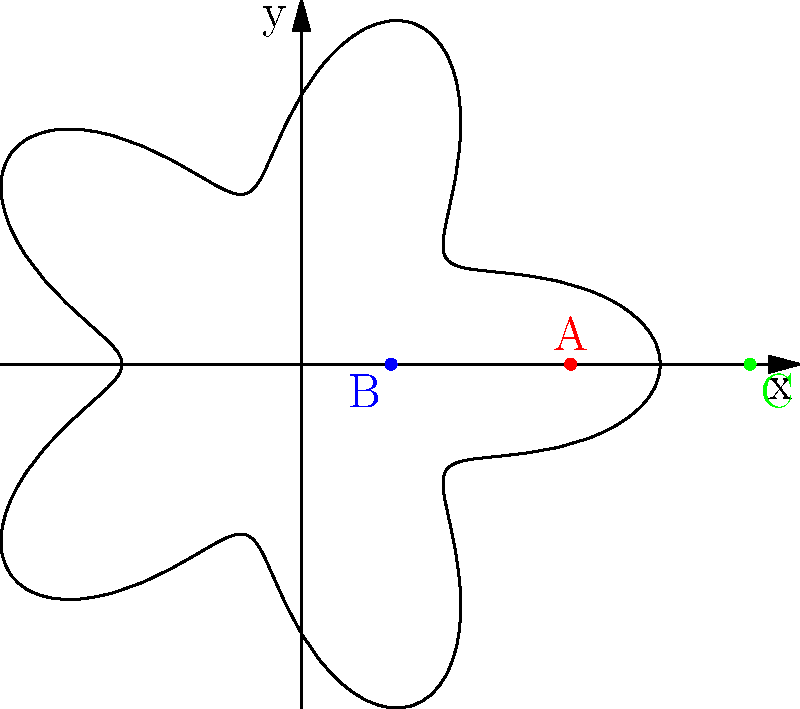In your latest portable speaker system design, you've mapped out optimal speaker placements using polar coordinates. The room is represented by the given polar graph, where the origin is the center of the room. Three potential speaker locations are marked: A (red), B (blue), and C (green). Which speaker location is closest to the room's perimeter at its angle, making it ideal for wall-mounted installation? To determine which speaker location is closest to the room's perimeter at its angle, we need to compare each point's distance from the origin to the value of the polar function at that angle. The polar function describing the room's perimeter is given by:

$$r(\theta) = 3 + \cos(5\theta)$$

Let's analyze each point:

1. Point A (red):
   - Coordinates: $(3, 0)$ in Cartesian, $(3, 0)$ in polar
   - At $\theta = 0$, $r(0) = 3 + \cos(0) = 4$
   - A is at distance 3, while the perimeter is at distance 4

2. Point B (blue):
   - Coordinates: $(1, 0)$ in Cartesian, $(1, 0)$ in polar
   - At $\theta = 0$, $r(0) = 3 + \cos(0) = 4$
   - B is at distance 1, while the perimeter is at distance 4

3. Point C (green):
   - Coordinates: $(5, 0)$ in Cartesian, $(5, 0)$ in polar
   - At $\theta = 0$, $r(0) = 3 + \cos(0) = 4$
   - C is at distance 5, while the perimeter is at distance 4

Comparing the distances:
- A: $|3 - 4| = 1$
- B: $|1 - 4| = 3$
- C: $|5 - 4| = 1$

Both A and C are 1 unit away from the perimeter, while B is 3 units away. However, C is outside the room, while A is inside. For wall-mounted installation, the point closest to but not exceeding the perimeter is ideal.
Answer: A (red point) 